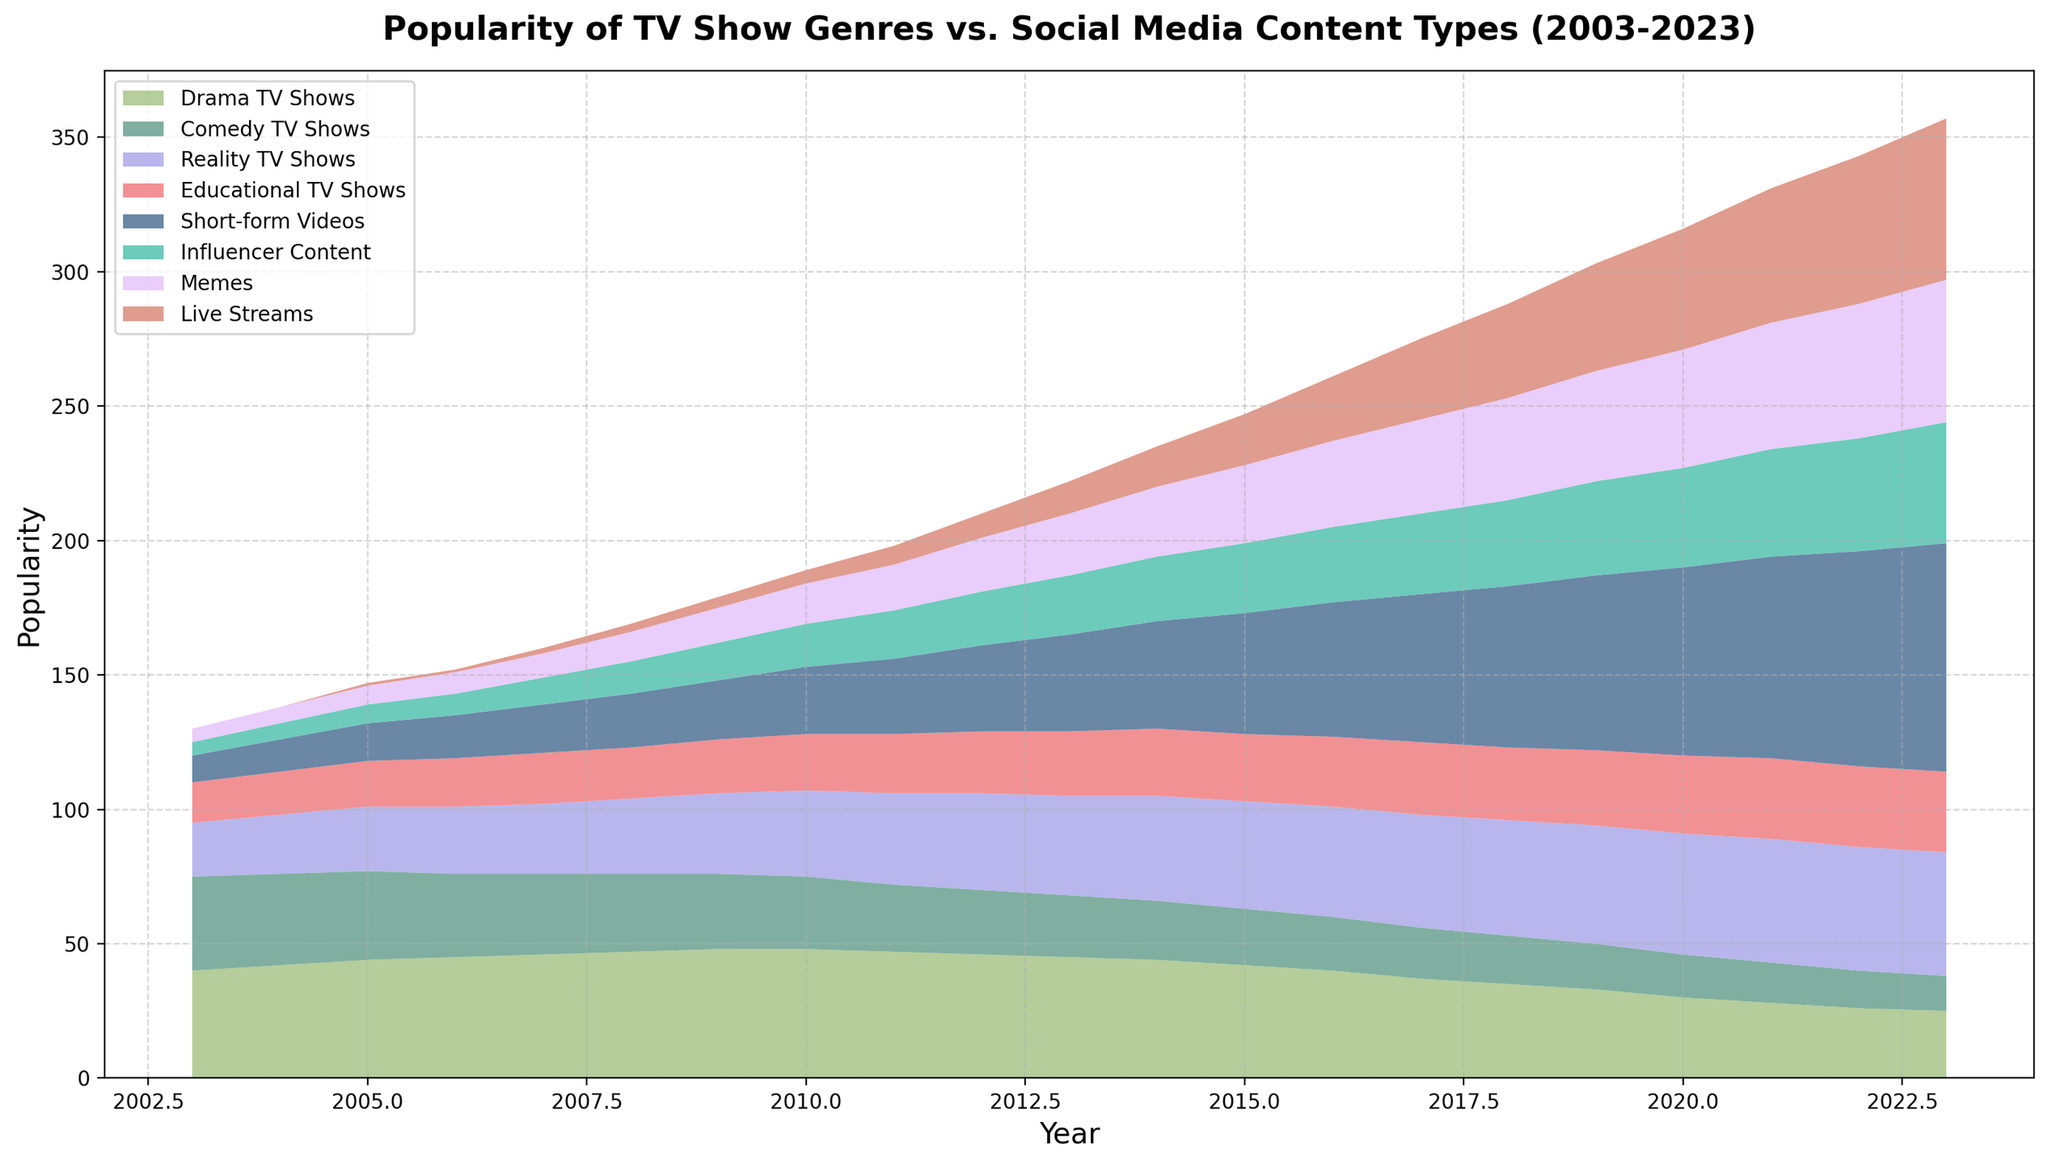What trend can be observed for the popularity of Drama TV Shows from 2003 to 2023? The popularity of Drama TV Shows gradually increased until around 2009, after which it started to decline steadily through 2023.
Answer: Declining Which type of TV show or social media content became the most popular by 2023? By observing the uppermost layer in the area chart for 2023, it is clear that Short-form Videos have the largest area, indicating they are the most popular type.
Answer: Short-form Videos How does the popularity of Comedy TV Shows in 2023 compare to its popularity in 2003? The area for Comedy TV Shows in 2023 is much smaller compared to 2003. Specifically, it went from being second in popularity to among the least popular.
Answer: Much less Based on the chart, what can you infer about the popularity trends of Reality TV Shows and Influencer Content from 2015 onwards? From 2015 onwards, Reality TV Shows' popularity remains relatively stable, while Influencer Content's popularity shows a rapid increase.
Answer: Reality stable, Influencer rising How did the popularity of Educational TV Shows change from 2003 to 2013, and what trend is observed from 2013 to 2023? From 2003 to 2013, the popularity of Educational TV Shows shows a gradual increase. After 2013, it remains relatively stable.
Answer: Increase, then stable Which genres or content types surpassed Drama TV Shows in popularity by 2023? By 2023, the genres or content types that surpassed Drama TV Shows in popularity are Short-form Videos, Influencer Content, and Memes.
Answer: Short-form Videos, Influencer Content, Memes Compare the change in popularity between Live Streams and Memes from 2015 to 2023. Memes and Live Streams both show an increasing trend from 2015 to 2023. However, the increase in popularity for Live Streams is noticeably steeper.
Answer: Both increasing, Live Streams steeper Between 2008 and 2010, which content type(s) experienced the most significant gain in popularity? By closely looking at the changes in the area between 2008 and 2010, Short-form Videos and Reality TV Shows exhibit significant gains.
Answer: Short-form Videos, Reality TV Shows What can be concluded about the trend of Influencer Content from 2003 to 2023? Influencer Content shows a consistent upward trend in popularity from its introduction around 2003, steadily increasing every year up to 2023.
Answer: Increasing steadily Out of all TV show genres, which one retained the most consistent level of popularity from 2003 to 2023? Educational TV Shows maintain a relatively stable level of popularity throughout the 20 years, with minor fluctuations.
Answer: Educational TV Shows 